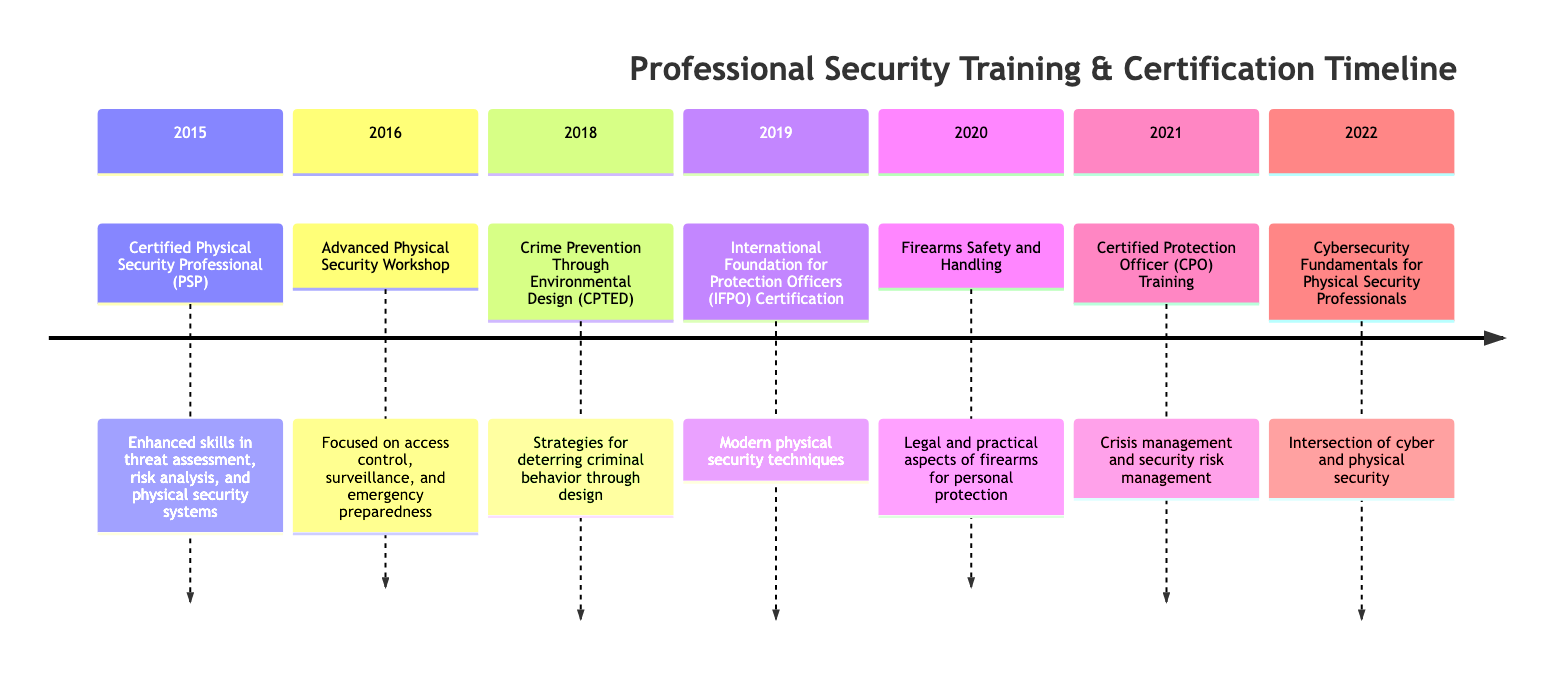What training or certification was completed in 2015? According to the timeline, the training or certification completed in 2015 was the "Certified Physical Security Professional (PSP)."
Answer: Certified Physical Security Professional (PSP) How many training programs or certifications were completed by 2022? The timeline lists seven entries from 2015 through 2022, indicating that seven training programs or certifications were completed.
Answer: 7 What was the focus of the Advanced Physical Security Workshop in 2016? The timeline specifies that the focus of the Advanced Physical Security Workshop was on access control, surveillance, and emergency preparedness.
Answer: Access control, surveillance, and emergency preparedness Which training program was focused on crime prevention through design? The timeline indicates that the "Crime Prevention Through Environmental Design (CPTED)" training program was specifically focused on strategies to deter criminal behavior through design.
Answer: Crime Prevention Through Environmental Design (CPTED) In what year was the Certified Protection Officer (CPO) Training completed? The timeline shows that the Certified Protection Officer (CPO) Training was completed in 2021.
Answer: 2021 What is the primary focus of the Cybersecurity Fundamentals for Physical Security Professionals course? The timeline outlines that the primary focus of the Cybersecurity Fundamentals for Physical Security Professionals course is on the intersection of cybersecurity and physical security.
Answer: Intersection of cyber and physical security Which two certifications in the timeline are specifically related to physical security? The two certifications specifically related to physical security mentioned in the timeline are "Certified Protection Officer (CPO) Training" and "International Foundation for Protection Officers (IFPO) Certification."
Answer: Certified Protection Officer (CPO) Training and International Foundation for Protection Officers (IFPO) Certification What year marks the completion of the Firearms Safety and Handling course? According to the timeline, the Firearms Safety and Handling course was completed in 2020.
Answer: 2020 